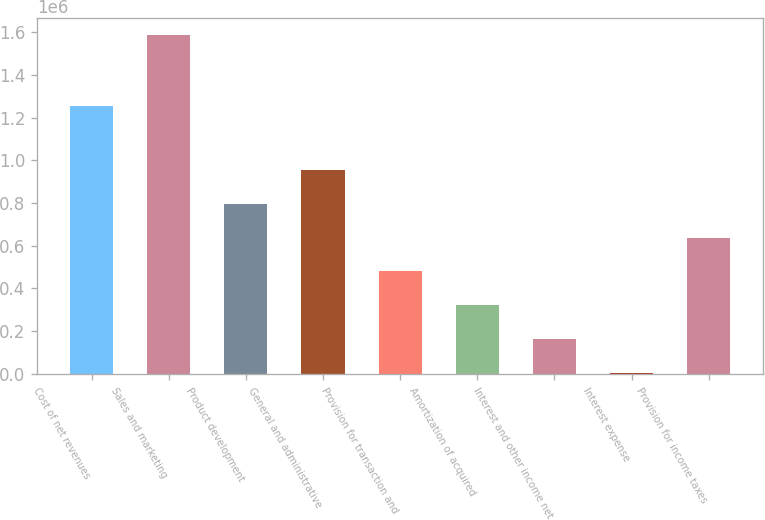Convert chart to OTSL. <chart><loc_0><loc_0><loc_500><loc_500><bar_chart><fcel>Cost of net revenues<fcel>Sales and marketing<fcel>Product development<fcel>General and administrative<fcel>Provision for transaction and<fcel>Amortization of acquired<fcel>Interest and other income net<fcel>Interest expense<fcel>Provision for income taxes<nl><fcel>1.25679e+06<fcel>1.58713e+06<fcel>796524<fcel>954646<fcel>480281<fcel>322159<fcel>164038<fcel>5916<fcel>638403<nl></chart> 